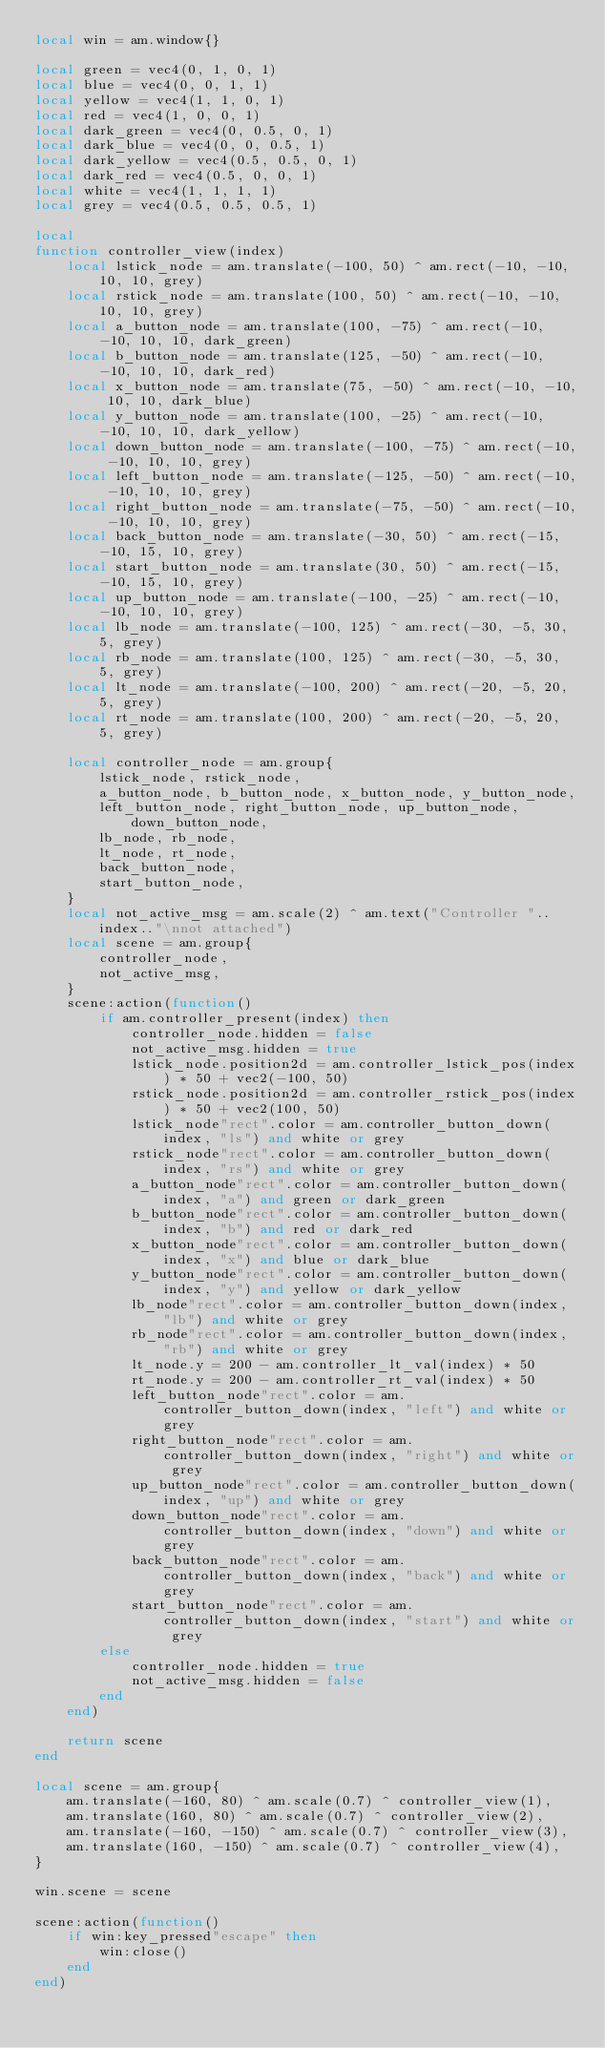Convert code to text. <code><loc_0><loc_0><loc_500><loc_500><_Lua_>local win = am.window{}

local green = vec4(0, 1, 0, 1)
local blue = vec4(0, 0, 1, 1)
local yellow = vec4(1, 1, 0, 1)
local red = vec4(1, 0, 0, 1)
local dark_green = vec4(0, 0.5, 0, 1)
local dark_blue = vec4(0, 0, 0.5, 1)
local dark_yellow = vec4(0.5, 0.5, 0, 1)
local dark_red = vec4(0.5, 0, 0, 1)
local white = vec4(1, 1, 1, 1)
local grey = vec4(0.5, 0.5, 0.5, 1)

local
function controller_view(index)
    local lstick_node = am.translate(-100, 50) ^ am.rect(-10, -10, 10, 10, grey)
    local rstick_node = am.translate(100, 50) ^ am.rect(-10, -10, 10, 10, grey)
    local a_button_node = am.translate(100, -75) ^ am.rect(-10, -10, 10, 10, dark_green)
    local b_button_node = am.translate(125, -50) ^ am.rect(-10, -10, 10, 10, dark_red)
    local x_button_node = am.translate(75, -50) ^ am.rect(-10, -10, 10, 10, dark_blue)
    local y_button_node = am.translate(100, -25) ^ am.rect(-10, -10, 10, 10, dark_yellow)
    local down_button_node = am.translate(-100, -75) ^ am.rect(-10, -10, 10, 10, grey)
    local left_button_node = am.translate(-125, -50) ^ am.rect(-10, -10, 10, 10, grey)
    local right_button_node = am.translate(-75, -50) ^ am.rect(-10, -10, 10, 10, grey)
    local back_button_node = am.translate(-30, 50) ^ am.rect(-15, -10, 15, 10, grey)
    local start_button_node = am.translate(30, 50) ^ am.rect(-15, -10, 15, 10, grey)
    local up_button_node = am.translate(-100, -25) ^ am.rect(-10, -10, 10, 10, grey)
    local lb_node = am.translate(-100, 125) ^ am.rect(-30, -5, 30, 5, grey)
    local rb_node = am.translate(100, 125) ^ am.rect(-30, -5, 30, 5, grey)
    local lt_node = am.translate(-100, 200) ^ am.rect(-20, -5, 20, 5, grey)
    local rt_node = am.translate(100, 200) ^ am.rect(-20, -5, 20, 5, grey)

    local controller_node = am.group{
        lstick_node, rstick_node,
        a_button_node, b_button_node, x_button_node, y_button_node,
        left_button_node, right_button_node, up_button_node, down_button_node,
        lb_node, rb_node,
        lt_node, rt_node,
        back_button_node,
        start_button_node,
    }
    local not_active_msg = am.scale(2) ^ am.text("Controller "..index.."\nnot attached")
    local scene = am.group{
        controller_node,
        not_active_msg,
    }
    scene:action(function()
        if am.controller_present(index) then
            controller_node.hidden = false
            not_active_msg.hidden = true
            lstick_node.position2d = am.controller_lstick_pos(index) * 50 + vec2(-100, 50)
            rstick_node.position2d = am.controller_rstick_pos(index) * 50 + vec2(100, 50)
            lstick_node"rect".color = am.controller_button_down(index, "ls") and white or grey
            rstick_node"rect".color = am.controller_button_down(index, "rs") and white or grey
            a_button_node"rect".color = am.controller_button_down(index, "a") and green or dark_green
            b_button_node"rect".color = am.controller_button_down(index, "b") and red or dark_red
            x_button_node"rect".color = am.controller_button_down(index, "x") and blue or dark_blue
            y_button_node"rect".color = am.controller_button_down(index, "y") and yellow or dark_yellow
            lb_node"rect".color = am.controller_button_down(index, "lb") and white or grey
            rb_node"rect".color = am.controller_button_down(index, "rb") and white or grey
            lt_node.y = 200 - am.controller_lt_val(index) * 50
            rt_node.y = 200 - am.controller_rt_val(index) * 50
            left_button_node"rect".color = am.controller_button_down(index, "left") and white or grey
            right_button_node"rect".color = am.controller_button_down(index, "right") and white or grey
            up_button_node"rect".color = am.controller_button_down(index, "up") and white or grey
            down_button_node"rect".color = am.controller_button_down(index, "down") and white or grey
            back_button_node"rect".color = am.controller_button_down(index, "back") and white or grey
            start_button_node"rect".color = am.controller_button_down(index, "start") and white or grey
        else
            controller_node.hidden = true
            not_active_msg.hidden = false
        end
    end)

    return scene
end

local scene = am.group{
    am.translate(-160, 80) ^ am.scale(0.7) ^ controller_view(1),
    am.translate(160, 80) ^ am.scale(0.7) ^ controller_view(2),
    am.translate(-160, -150) ^ am.scale(0.7) ^ controller_view(3),
    am.translate(160, -150) ^ am.scale(0.7) ^ controller_view(4),
}

win.scene = scene

scene:action(function()
    if win:key_pressed"escape" then
        win:close()
    end
end)
</code> 